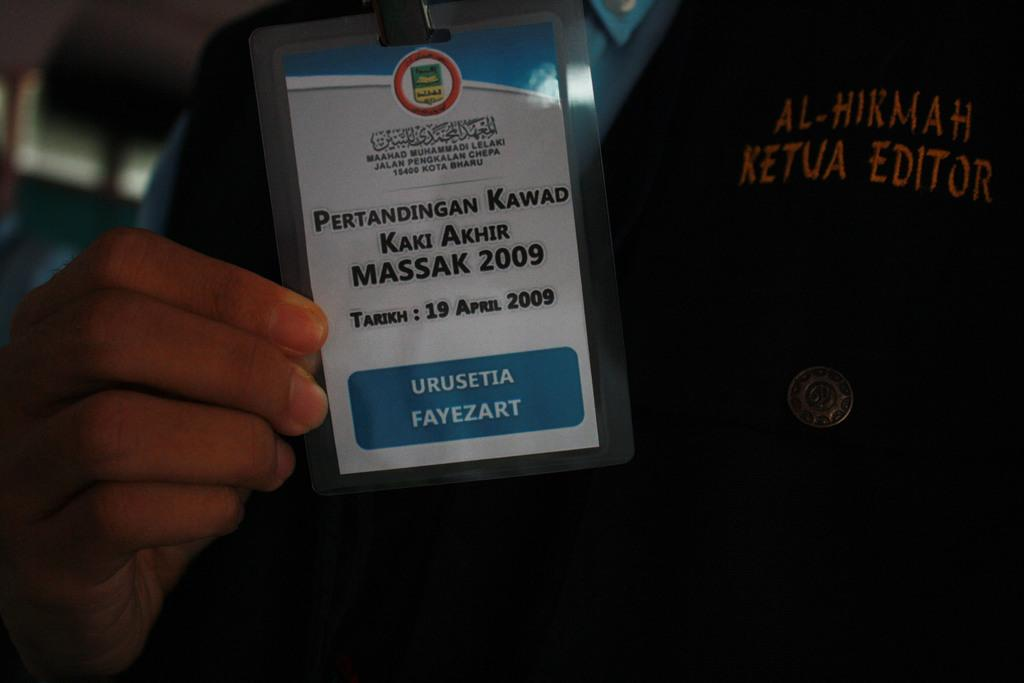Who is present in the image? There is a person in the image. What is the person doing with their ID card? The person is showing their ID card. How is the person holding the ID card? The person is holding the ID card with their hand. What type of thread is being used to sew the bubble in the image? There is no thread, bubble, or sewing activity present in the image. 